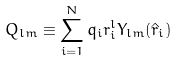Convert formula to latex. <formula><loc_0><loc_0><loc_500><loc_500>Q _ { l m } \equiv \sum _ { i = 1 } ^ { N } q _ { i } r _ { i } ^ { l } Y _ { l m } ( \hat { r } _ { i } )</formula> 